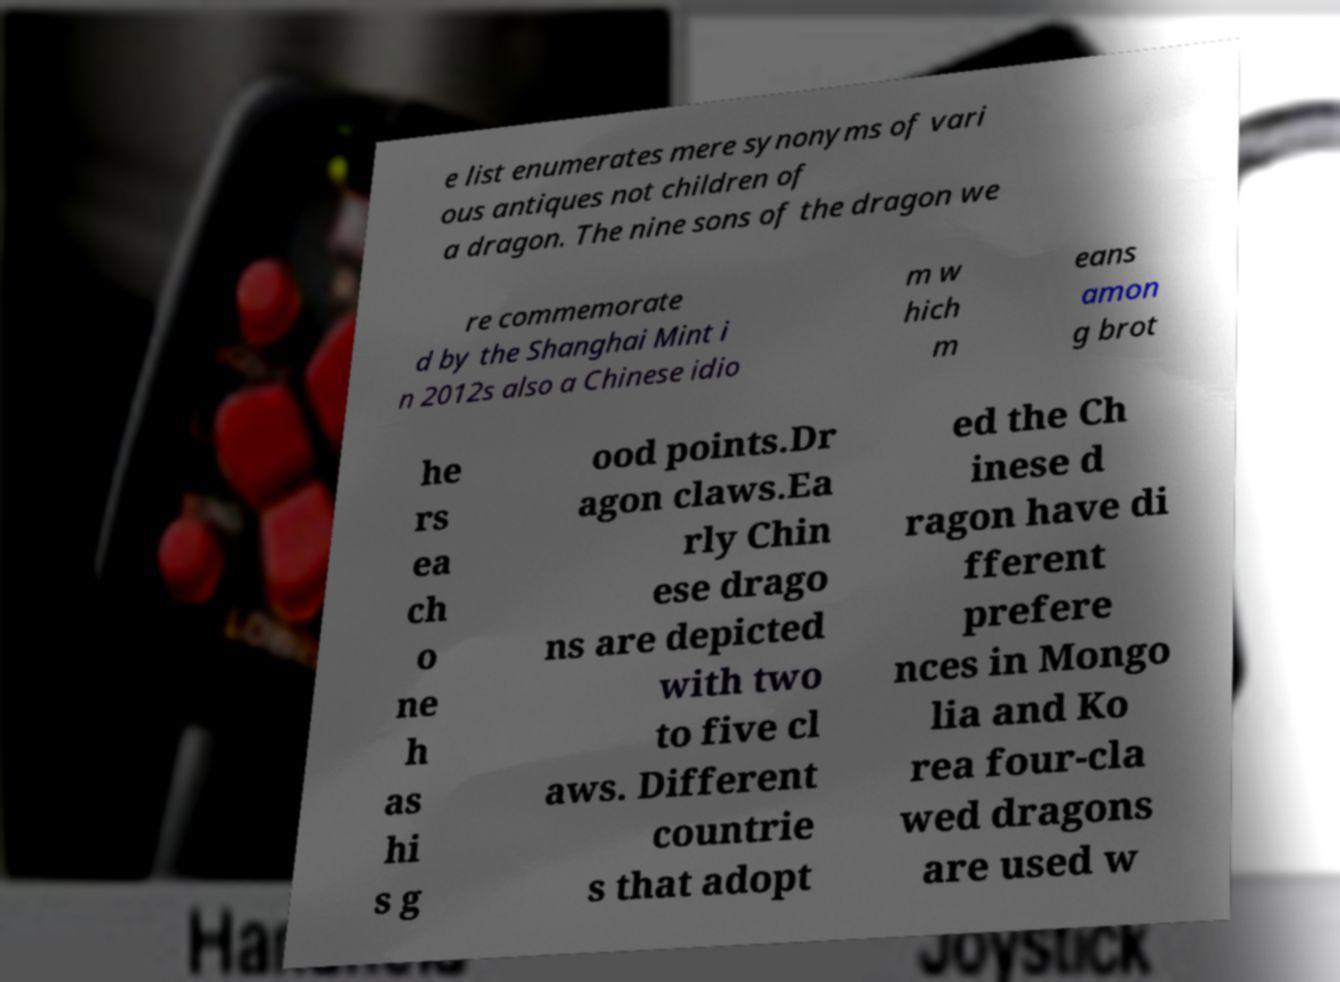Can you read and provide the text displayed in the image?This photo seems to have some interesting text. Can you extract and type it out for me? e list enumerates mere synonyms of vari ous antiques not children of a dragon. The nine sons of the dragon we re commemorate d by the Shanghai Mint i n 2012s also a Chinese idio m w hich m eans amon g brot he rs ea ch o ne h as hi s g ood points.Dr agon claws.Ea rly Chin ese drago ns are depicted with two to five cl aws. Different countrie s that adopt ed the Ch inese d ragon have di fferent prefere nces in Mongo lia and Ko rea four-cla wed dragons are used w 